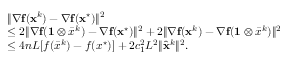<formula> <loc_0><loc_0><loc_500><loc_500>\begin{array} { r l } & { \| { \nabla } f ( x ^ { k } ) - { \nabla } { f } ( { x } ^ { ^ { * } } ) \| ^ { 2 } } \\ & { \leq 2 \| { \nabla } f ( 1 \otimes \bar { x } ^ { k } ) - { \nabla } f ( { x } ^ { ^ { * } } ) \| ^ { 2 } + 2 \| { \nabla } f ( x ^ { k } ) - { \nabla } f ( 1 \otimes \bar { x } ^ { k } ) \| ^ { 2 } } \\ & { \leq 4 n L [ f ( \bar { x } ^ { k } ) - f ( x ^ { ^ { * } } ) ] + 2 c _ { 1 } ^ { 2 } L ^ { 2 } \| \hat { x } ^ { k } \| ^ { 2 } . } \end{array}</formula> 